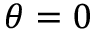<formula> <loc_0><loc_0><loc_500><loc_500>\theta = 0</formula> 